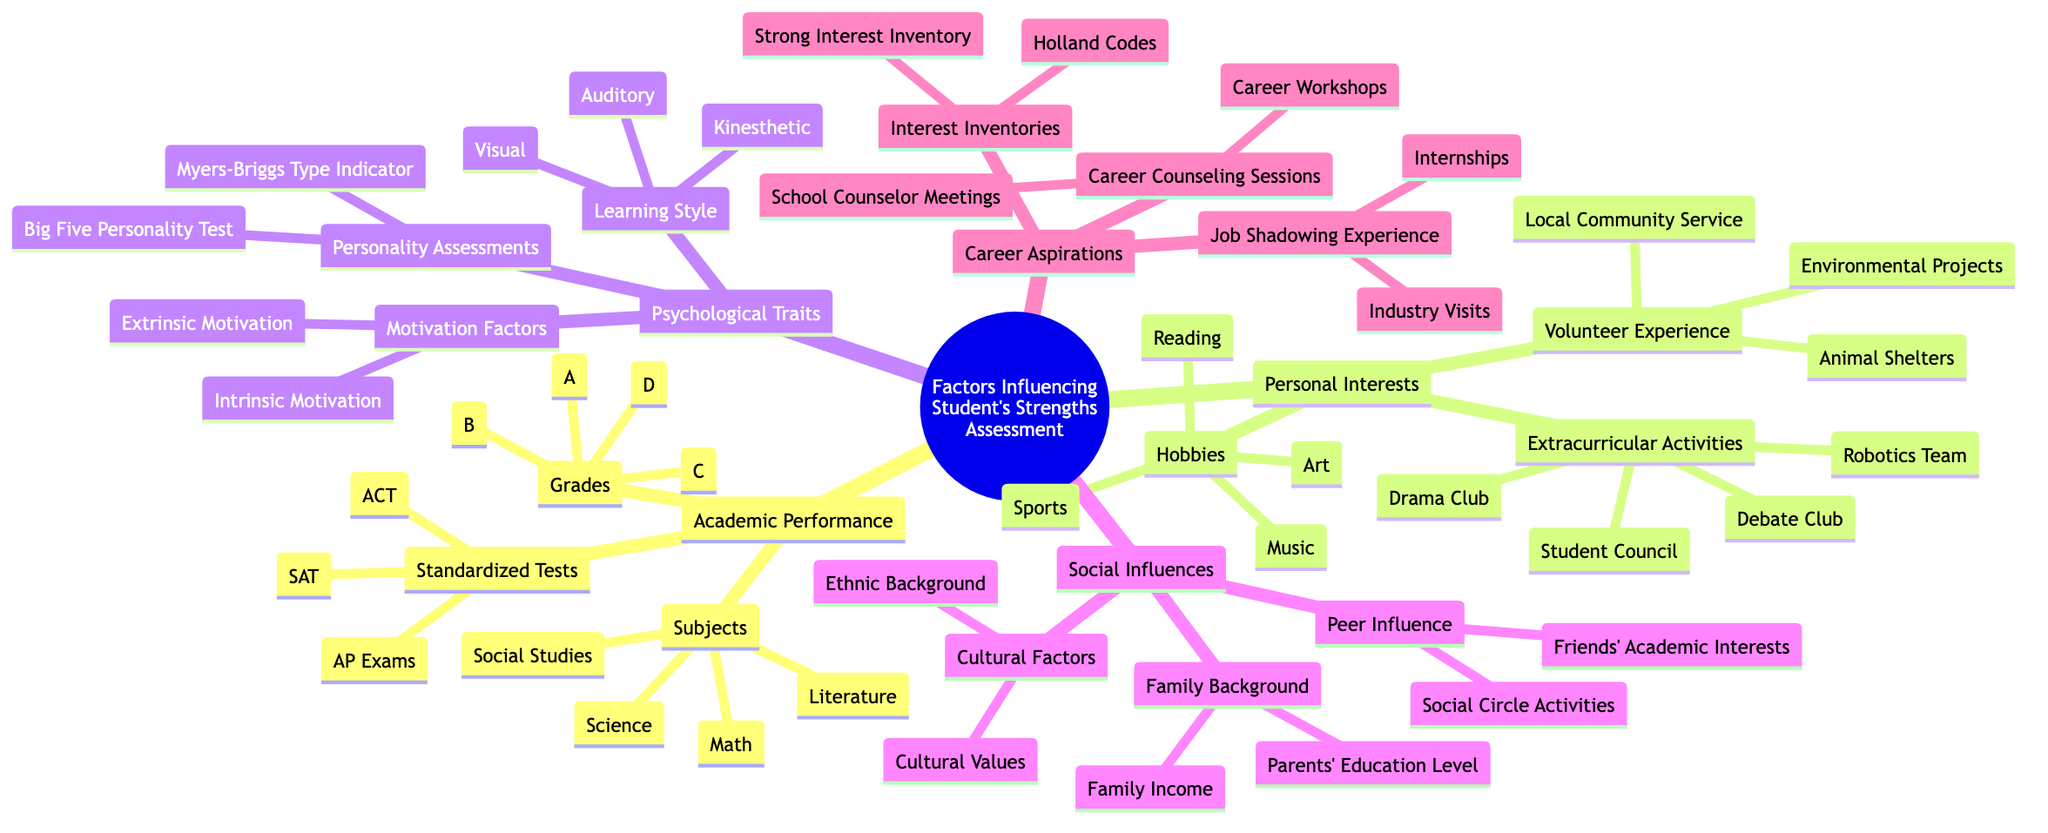What are the subjects under Academic Performance? The diagram lists four subjects under the 'Academic Performance' node. These subjects are Math, Science, Literature, and Social Studies.
Answer: Math, Science, Literature, Social Studies How many grades are listed in the Grades category? Under the 'Grades' node, there are four choices: A, B, C, and D. Therefore, the total number of grades listed is four.
Answer: 4 What are the two personality assessments mentioned in Psychological Traits? The node 'Personality Assessments' contains two specific assessments: Myers-Briggs Type Indicator and Big Five Personality Test.
Answer: Myers-Briggs Type Indicator, Big Five Personality Test Which influence involves Parents' Education Level? The 'Family Background' subcategory under 'Social Influences' specifically mentions Parents' Education Level as a factor impacting student's strengths assessment.
Answer: Family Background What types of motivation factors are identified in Psychological Traits? In the node under 'Motivation Factors', there are two types listed, which are Intrinsic Motivation and Extrinsic Motivation, proving the various sources of motivation.
Answer: Intrinsic Motivation, Extrinsic Motivation What types of activities are included under Personal Interests? The 'Personal Interests' node has three main branches, which include Hobbies, Extracurricular Activities, and Volunteer Experience as the main types of activities categorizing interests.
Answer: Hobbies, Extracurricular Activities, Volunteer Experience How many standardized tests are mentioned under Academic Performance? There are three standardized tests listed: SAT, ACT, and AP Exams, giving a total of three tests that can affect a student's academic standing.
Answer: 3 What type of experience is associated with Job Shadowing? The node pertaining to 'Job Shadowing Experience' features two aspects: Internships and Industry Visits, highlighting the types of experiences valuable for students' career aspirations.
Answer: Internships, Industry Visits 